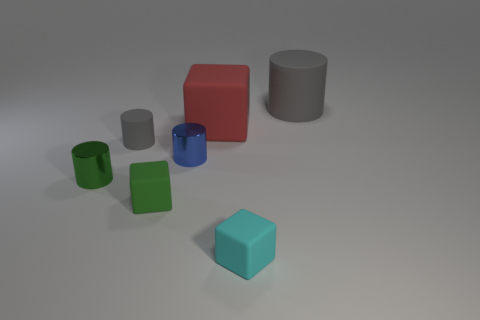Subtract all gray cylinders. How many were subtracted if there are1gray cylinders left? 1 Subtract all purple cylinders. Subtract all red blocks. How many cylinders are left? 4 Add 1 tiny cubes. How many objects exist? 8 Subtract all cubes. How many objects are left? 4 Subtract 1 green blocks. How many objects are left? 6 Subtract all big yellow cylinders. Subtract all tiny matte cubes. How many objects are left? 5 Add 7 gray matte things. How many gray matte things are left? 9 Add 2 large gray matte things. How many large gray matte things exist? 3 